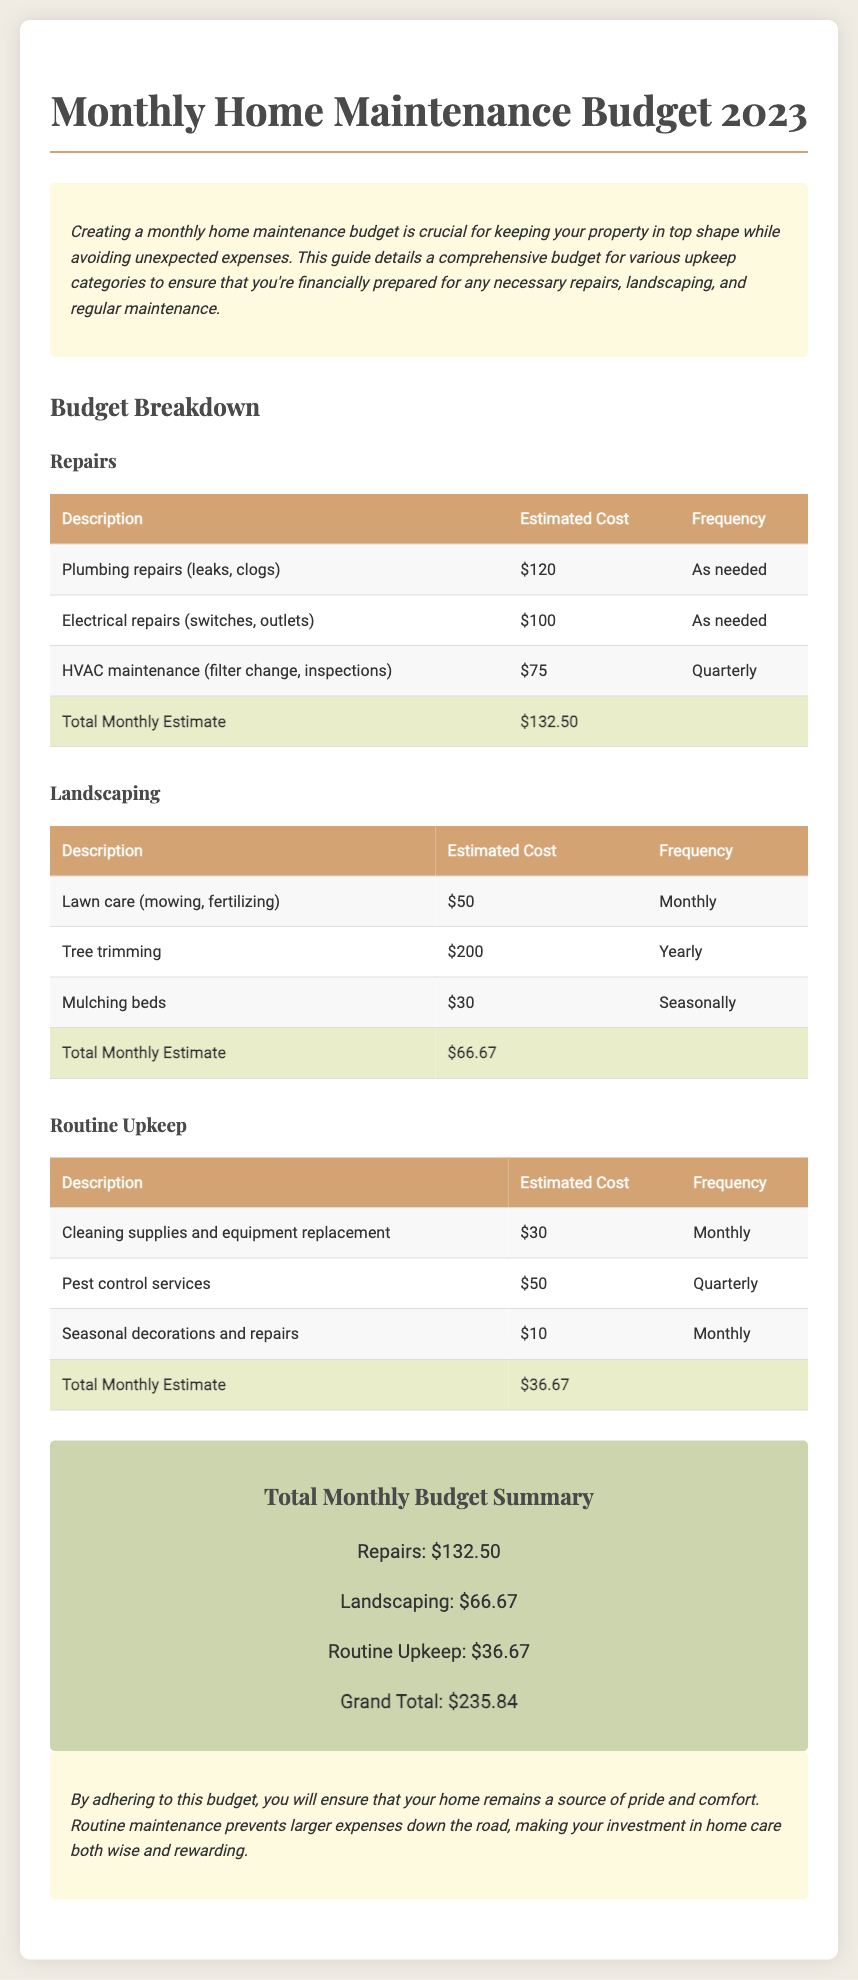what is the total estimated cost for repairs? The total estimated cost for repairs can be found in the "Total Monthly Estimate" row for the Repairs section, which is $132.50.
Answer: $132.50 how often is HVAC maintenance performed? The frequency of HVAC maintenance is stated in the table, which is quarterly.
Answer: Quarterly what is the estimated cost for tree trimming? The estimated cost for tree trimming is specified in the Landscaping table as $200.
Answer: $200 what is the total monthly estimate for landscaping? The total monthly estimate for landscaping is located in the Landscaping section and is $66.67.
Answer: $66.67 how much is allocated for cleaning supplies and equipment replacement? The estimated cost for cleaning supplies and equipment replacement is listed in the Routine Upkeep table, which is $30.
Answer: $30 what is the grand total for the monthly home maintenance budget? The grand total for the budget can be found in the Grand Total Summary section, which sums all categories to $235.84.
Answer: $235.84 which section has the highest total monthly estimate? The Repairs section has the highest total monthly estimate of $132.50.
Answer: Repairs how many categories are listed in the budget? The budget includes three categories: Repairs, Landscaping, and Routine Upkeep.
Answer: Three what service is provided quarterly under Routine Upkeep? The service provided quarterly under Routine Upkeep is Pest control services.
Answer: Pest control services 